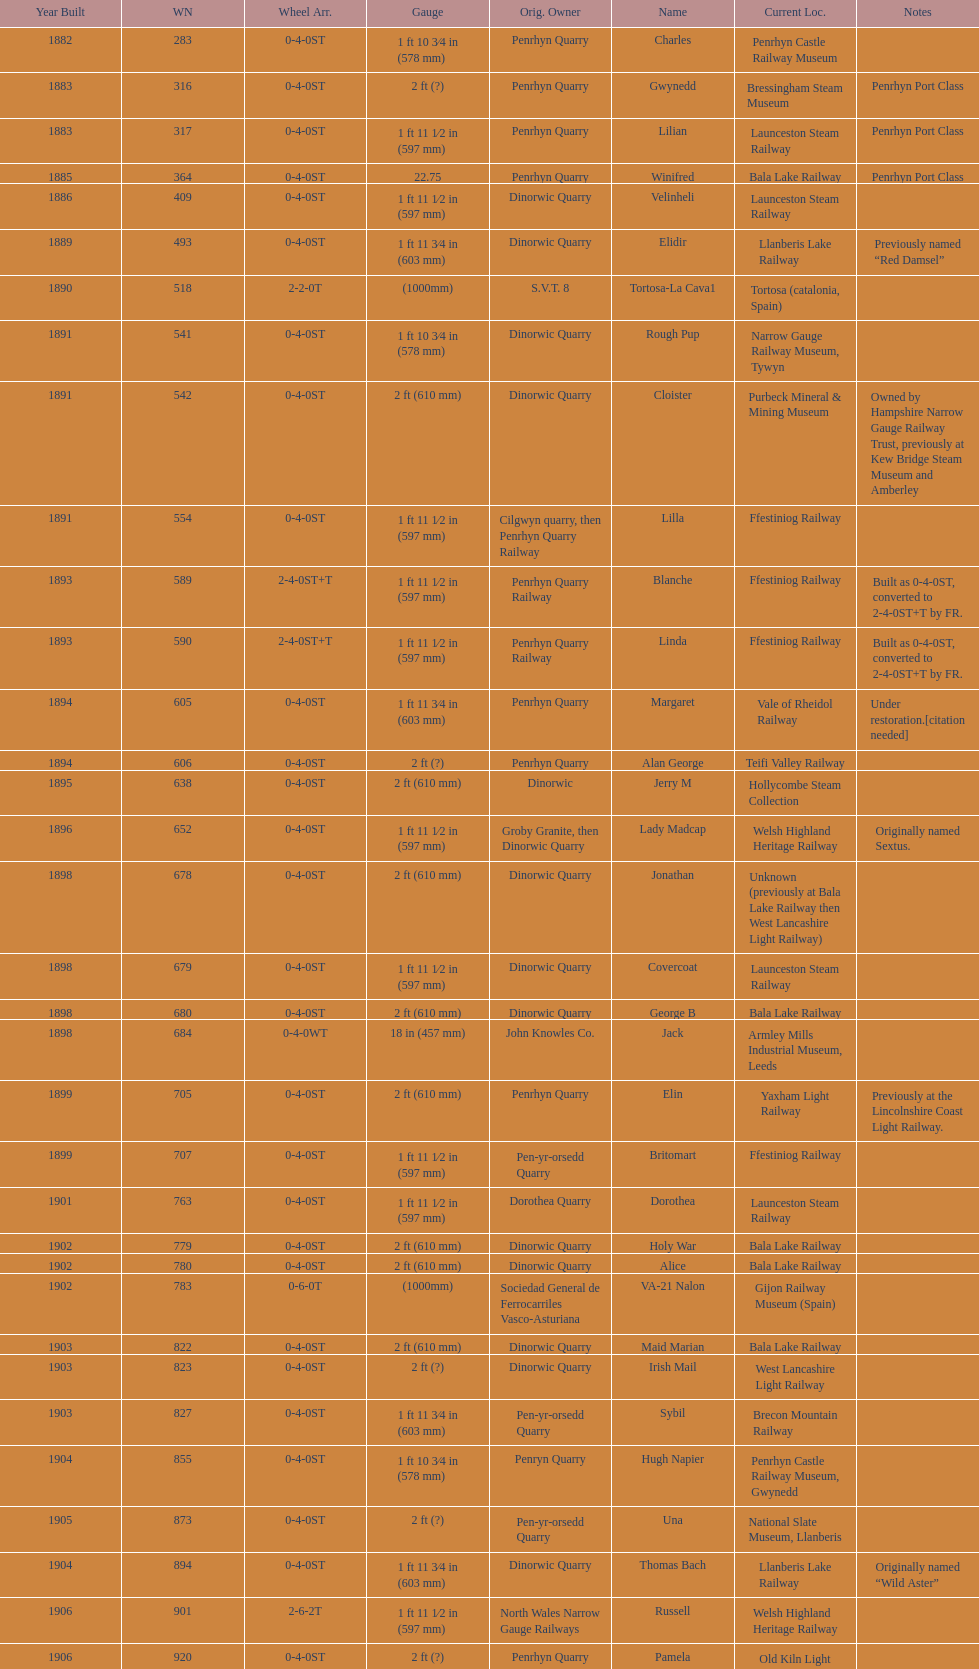Who owned the last locomotive to be built? Trangkil Sugar Mill, Indonesia. 